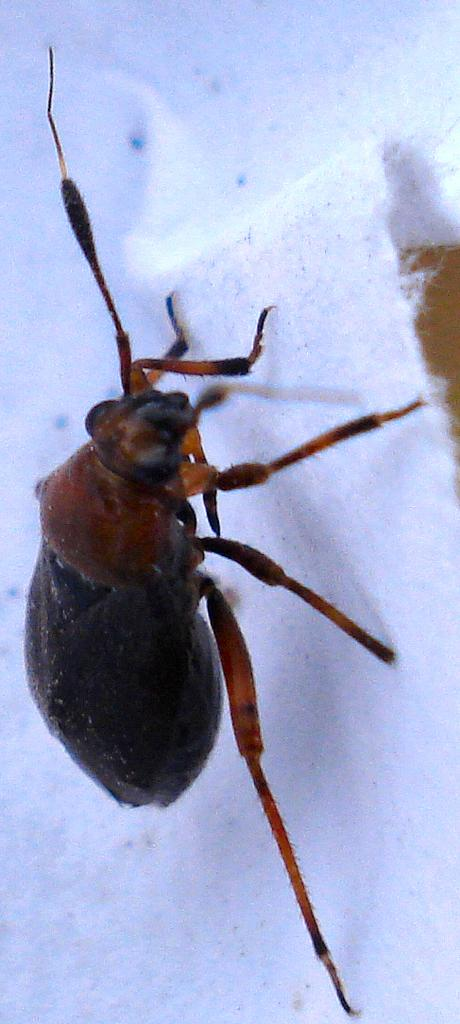What type of animal can be seen in the image? There is a spider in the image. Can you tell me how many crows are visible in the image? There are no crows present in the image; it features a spider. What type of kick is being performed by the spider in the image? There is no kick being performed by the spider in the image, as spiders do not have the ability to kick. 